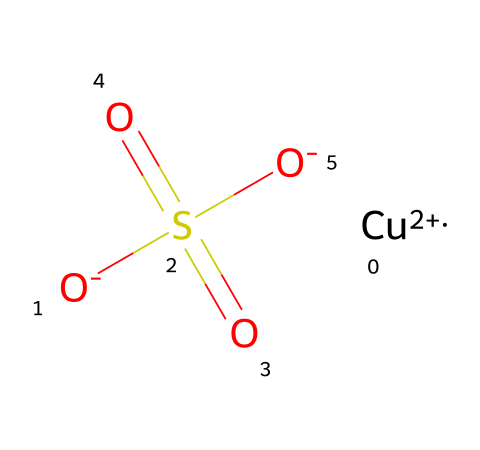What is the total number of oxygen atoms in the chemical? Inspecting the SMILES representation, we can identify that the molecule contains three oxygen atoms: one attached to sulfur and two that are part of the sulfonate group (S(=O)(=O)).
Answer: three What is the oxidation state of copper in this chemical? The notation [Cu+2] in the SMILES indicates that copper has a +2 oxidation state, which is a result of losing two electrons.
Answer: +2 How many sulfate groups are present in this chemical? Looking at the structure, the SO4 configuration implies that there is one sulfate group in the molecule, as indicated by the sulfonate representation S(=O)(=O)[O-].
Answer: one How many total bonds are represented in this molecule? In the structure, we see that copper forms ionic bonds with the sulfate ions, and the sulfur has four bonds: two double bonds to oxygen and two single bonds to oxygen. Adding one bond to copper results in a total of five bonds in this molecule.
Answer: five What type of chemical is copper sulfate primarily used as? Based on the structure and common knowledge, copper sulfate is mainly used as a fungicide and algaecide, particularly in swimming pools.
Answer: fungicide and algaecide What is the molecular formula for this compound? Observing the components in the SMILES: one copper (Cu), four oxygen (O), and one sulfur (S) gives us the molecular formula: CuSO4.
Answer: CuSO4 